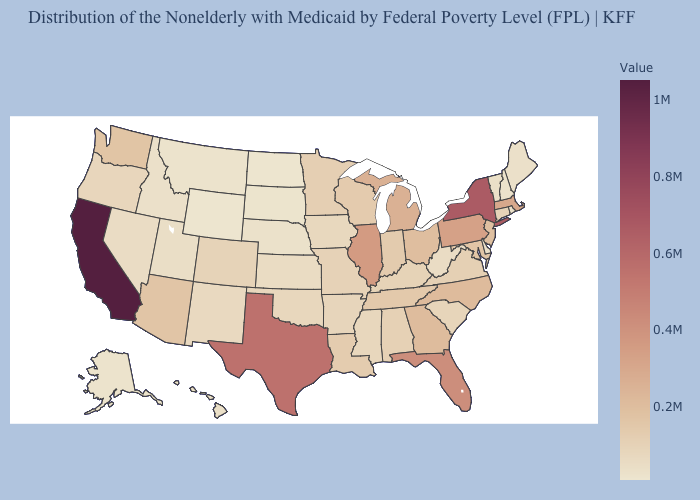Is the legend a continuous bar?
Give a very brief answer. Yes. Among the states that border Oklahoma , which have the highest value?
Quick response, please. Texas. Among the states that border Florida , does Alabama have the highest value?
Short answer required. No. Does North Carolina have a higher value than West Virginia?
Give a very brief answer. Yes. 